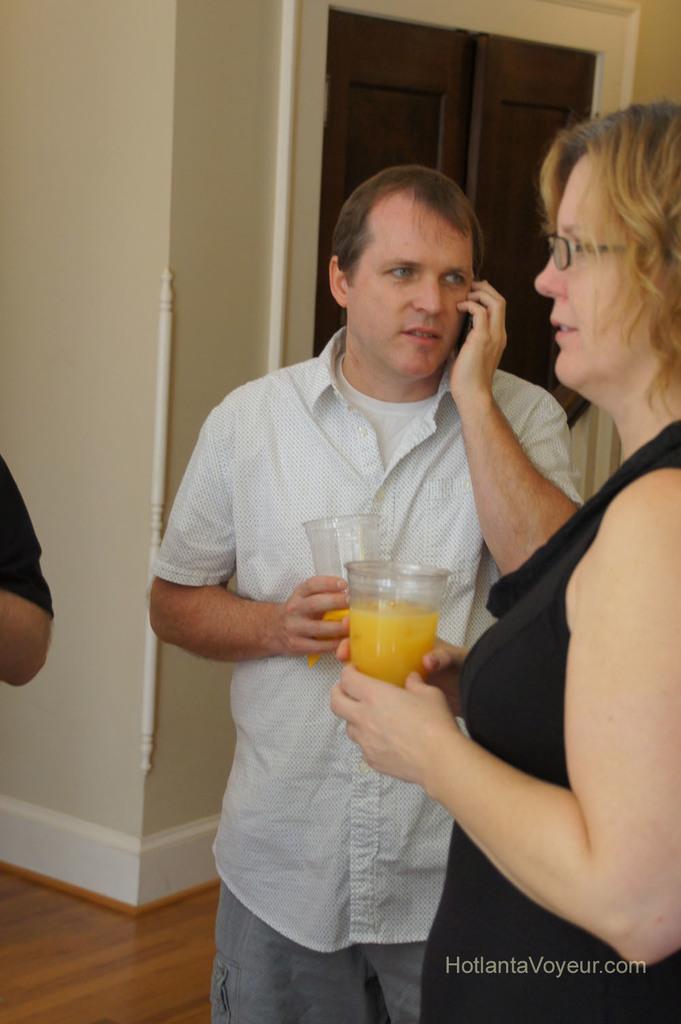In one or two sentences, can you explain what this image depicts? This picture is clicked inside. On the right there is a woman wearing black color dress, holding a glass of juice and standing on the ground and there is a man wearing a white color shirt, holding a glass of juice, standing on the ground and seems to be talking on the mobile phone. On the left corner there is a person. In the background there is a wooden door and the wall. At the bottom right corner there is a text on the image. 